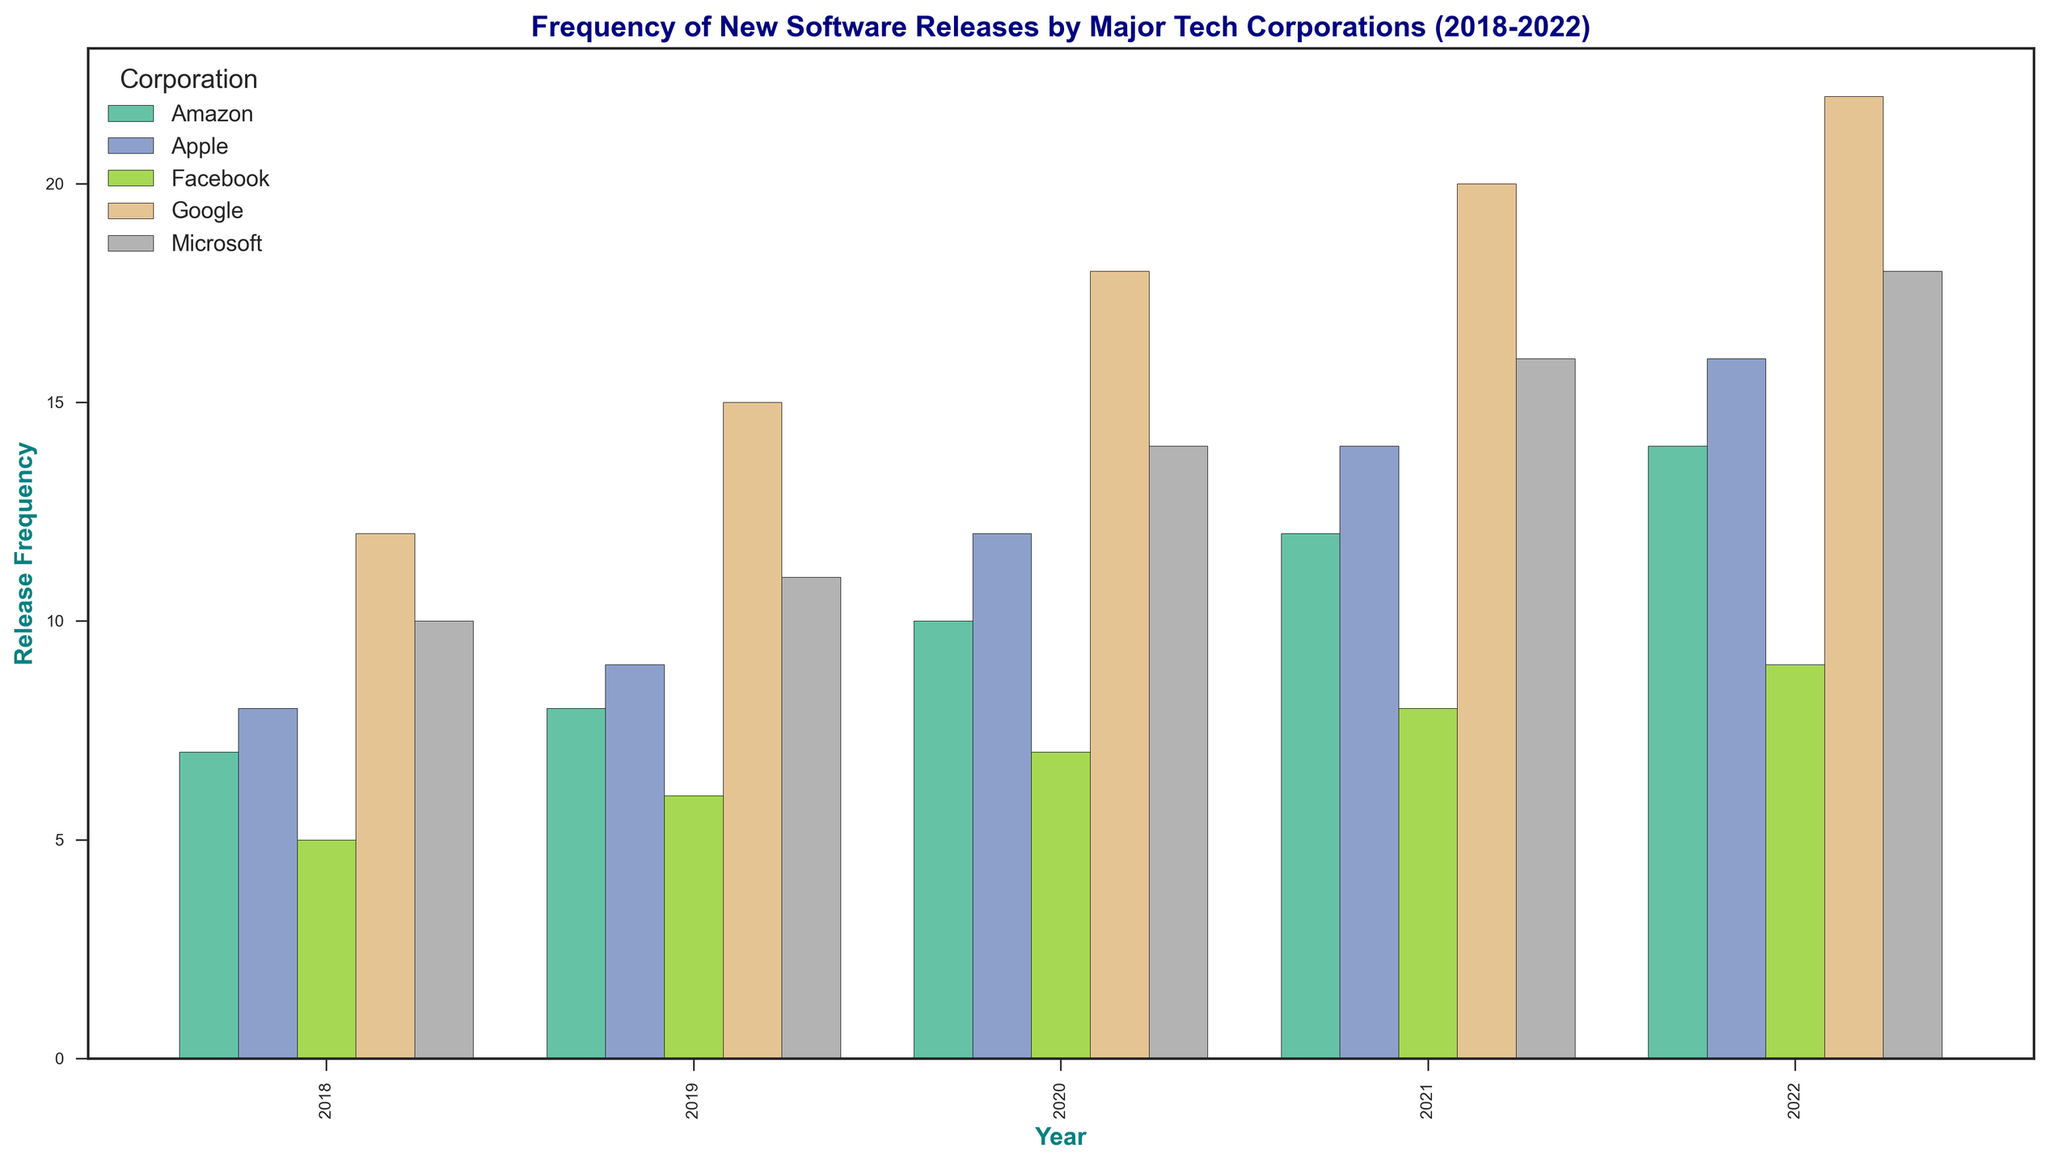What is the release frequency for Facebook in 2020? Look at the bar in the year 2020 corresponding to Facebook, which is marked in one of the distinct colors. The height of this bar indicates the release frequency for Facebook in 2020.
Answer: 7 Which corporation had the highest number of releases in 2021? Compare the heights of the bars for all corporations in the year 2021. The tallest bar represents the corporation with the highest number of releases.
Answer: Google Did Apple's release frequency increase or decrease from 2019 to 2020? Check the height of Apple's bars for the years 2019 and 2020. Compare these heights to determine if there was an increase or decrease.
Answer: Increase What is the total number of software releases by Amazon over the five-year period? Add up the release frequencies for Amazon from each year: 7 (2018) + 8 (2019) + 10 (2020) + 12 (2021) + 14 (2022).
Answer: 51 Which corporation showed the most consistent growth in software releases from 2018 to 2022? Examine the trend of release frequencies over the years for each corporation. The most consistent growth would have bars that incrementally increase each year.
Answer: Google How does Microsoft’s release frequency in 2022 compare to its release frequency in 2018? Compare the height of the bars for Microsoft in the years 2018 and 2022. Check which one is taller or if they are the same height.
Answer: Increase What is the average release frequency for Apple over the entire period? Add up the release frequencies for Apple from each year and divide by the number of years: (8 + 9 + 12 + 14 + 16) / 5.
Answer: 11.8 In which year did Facebook have its highest release frequency, and what was the value? Look at each bar corresponding to Facebook across all years and find the year with the tallest bar, which represents the highest release frequency.
Answer: 2022, 9 Compare the change in release frequency for Google between 2019 and 2021 to that of Amazon over the same period. Which corporation had the larger change? Calculate the difference in Google’s frequencies from 2019 to 2021: 20 - 15. Then, calculate the difference in Amazon's frequencies for the same period: 12 - 8. Compare the two differences.
Answer: Google Did any corporation have a decrease in release frequency from 2021 to 2022? Compare the heights of the bars for each corporation between the years 2021 and 2022 to see if any bars are shorter in 2022.
Answer: No 